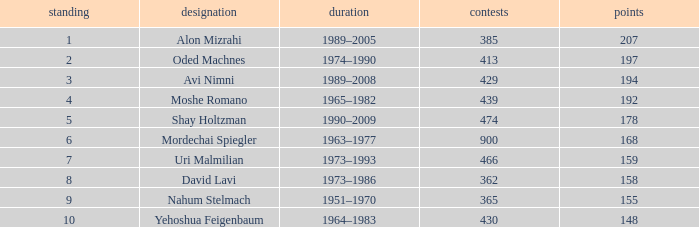What is the Rank of the player with 362 Matches? 8.0. 